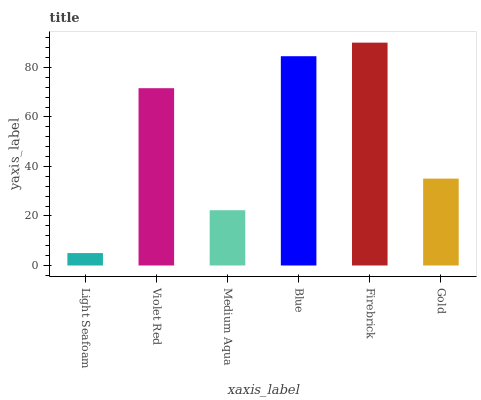Is Light Seafoam the minimum?
Answer yes or no. Yes. Is Firebrick the maximum?
Answer yes or no. Yes. Is Violet Red the minimum?
Answer yes or no. No. Is Violet Red the maximum?
Answer yes or no. No. Is Violet Red greater than Light Seafoam?
Answer yes or no. Yes. Is Light Seafoam less than Violet Red?
Answer yes or no. Yes. Is Light Seafoam greater than Violet Red?
Answer yes or no. No. Is Violet Red less than Light Seafoam?
Answer yes or no. No. Is Violet Red the high median?
Answer yes or no. Yes. Is Gold the low median?
Answer yes or no. Yes. Is Blue the high median?
Answer yes or no. No. Is Firebrick the low median?
Answer yes or no. No. 